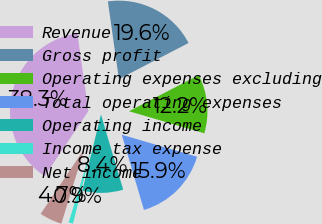Convert chart to OTSL. <chart><loc_0><loc_0><loc_500><loc_500><pie_chart><fcel>Revenue<fcel>Gross profit<fcel>Operating expenses excluding<fcel>Total operating expenses<fcel>Operating income<fcel>Income tax expense<fcel>Net income<nl><fcel>38.34%<fcel>19.63%<fcel>12.15%<fcel>15.89%<fcel>8.4%<fcel>0.92%<fcel>4.66%<nl></chart> 